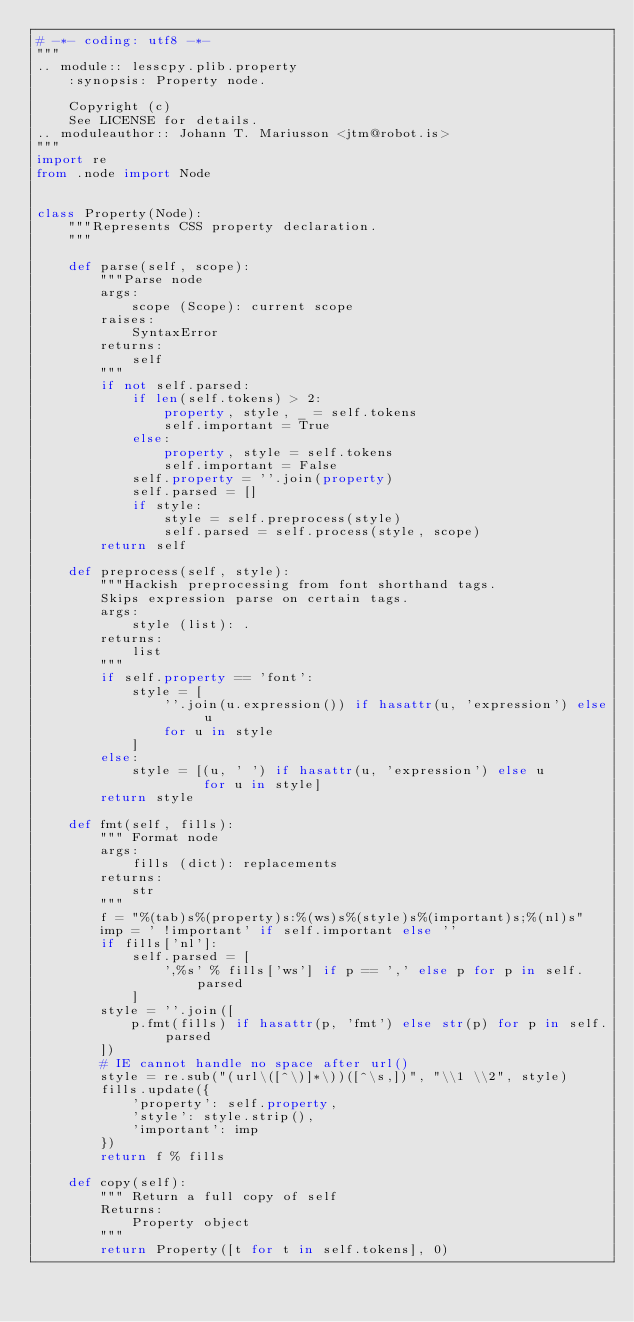<code> <loc_0><loc_0><loc_500><loc_500><_Python_># -*- coding: utf8 -*-
"""
.. module:: lesscpy.plib.property
    :synopsis: Property node.

    Copyright (c)
    See LICENSE for details.
.. moduleauthor:: Johann T. Mariusson <jtm@robot.is>
"""
import re
from .node import Node


class Property(Node):
    """Represents CSS property declaration.
    """

    def parse(self, scope):
        """Parse node
        args:
            scope (Scope): current scope
        raises:
            SyntaxError
        returns:
            self
        """
        if not self.parsed:
            if len(self.tokens) > 2:
                property, style, _ = self.tokens
                self.important = True
            else:
                property, style = self.tokens
                self.important = False
            self.property = ''.join(property)
            self.parsed = []
            if style:
                style = self.preprocess(style)
                self.parsed = self.process(style, scope)
        return self

    def preprocess(self, style):
        """Hackish preprocessing from font shorthand tags.
        Skips expression parse on certain tags.
        args:
            style (list): .
        returns:
            list
        """
        if self.property == 'font':
            style = [
                ''.join(u.expression()) if hasattr(u, 'expression') else u
                for u in style
            ]
        else:
            style = [(u, ' ') if hasattr(u, 'expression') else u
                     for u in style]
        return style

    def fmt(self, fills):
        """ Format node
        args:
            fills (dict): replacements
        returns:
            str
        """
        f = "%(tab)s%(property)s:%(ws)s%(style)s%(important)s;%(nl)s"
        imp = ' !important' if self.important else ''
        if fills['nl']:
            self.parsed = [
                ',%s' % fills['ws'] if p == ',' else p for p in self.parsed
            ]
        style = ''.join([
            p.fmt(fills) if hasattr(p, 'fmt') else str(p) for p in self.parsed
        ])
        # IE cannot handle no space after url()
        style = re.sub("(url\([^\)]*\))([^\s,])", "\\1 \\2", style)
        fills.update({
            'property': self.property,
            'style': style.strip(),
            'important': imp
        })
        return f % fills

    def copy(self):
        """ Return a full copy of self
        Returns:
            Property object
        """
        return Property([t for t in self.tokens], 0)
</code> 